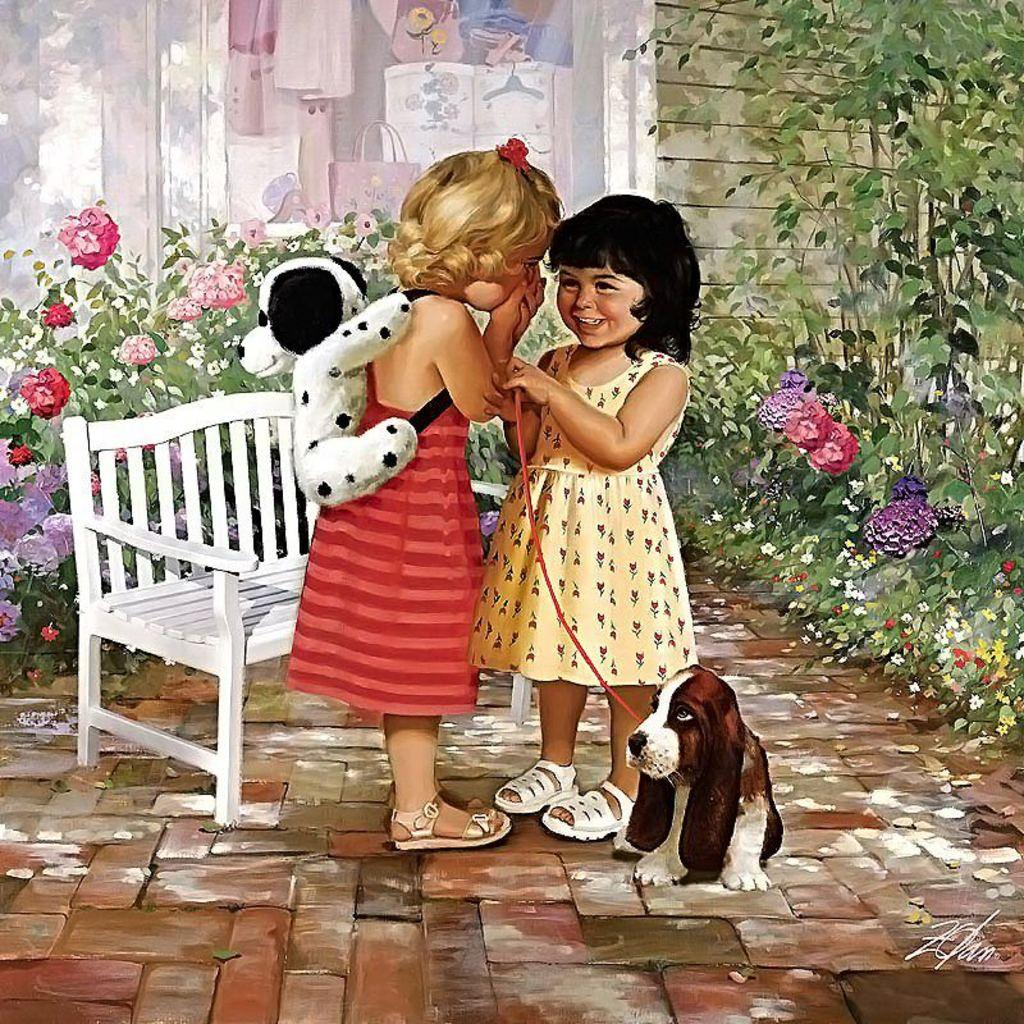What is the girl in the image wearing? There is a girl wearing a bag in the image. How many girls are in the image? There are two girls in the image. What is the second girl doing? The second girl is smiling and holding a puppy. What is the setting of the image? There is a bench, flowers, trees, and a wall in the background of the image. How many baskets can be seen in the image? There are no baskets present in the image. Is there a bridge visible in the image? No, there is no bridge visible in the image. 